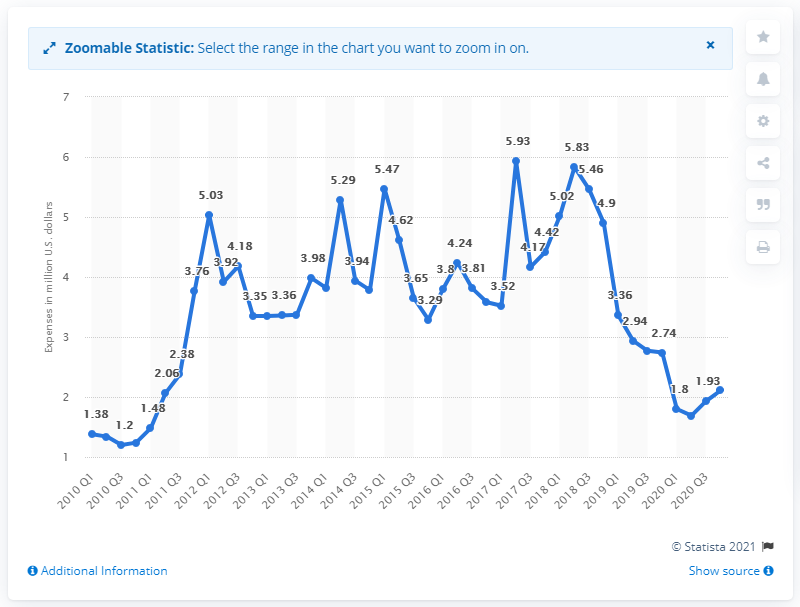Outline some significant characteristics in this image. In the third quarter of 2020, Google reported spending 1.93 million dollars on lobbying efforts in the United States. Google spent $1.93 million on lobbying in the United States in the third quarter of 2020. 